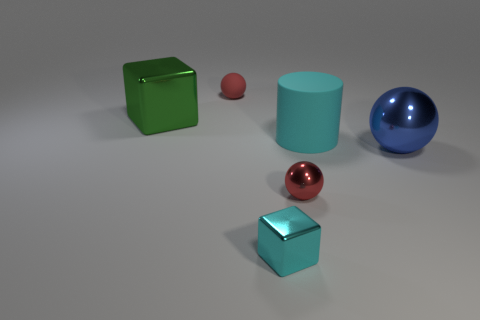What size is the metallic object on the left side of the block that is right of the red sphere that is behind the green metal block?
Make the answer very short. Large. Are there any blue spheres?
Your response must be concise. Yes. What material is the thing that is the same color as the rubber cylinder?
Keep it short and to the point. Metal. How many large matte cylinders are the same color as the large sphere?
Your answer should be very brief. 0. What number of things are either small red spheres that are in front of the matte ball or red balls that are on the right side of the cyan metal block?
Ensure brevity in your answer.  1. There is a small sphere that is right of the tiny red rubber object; how many large blue spheres are right of it?
Make the answer very short. 1. What color is the tiny thing that is made of the same material as the big cylinder?
Make the answer very short. Red. Is there a purple metallic sphere of the same size as the green metallic block?
Ensure brevity in your answer.  No. What is the shape of the shiny object that is the same size as the red shiny ball?
Provide a succinct answer. Cube. Is there a red thing that has the same shape as the cyan rubber thing?
Give a very brief answer. No. 